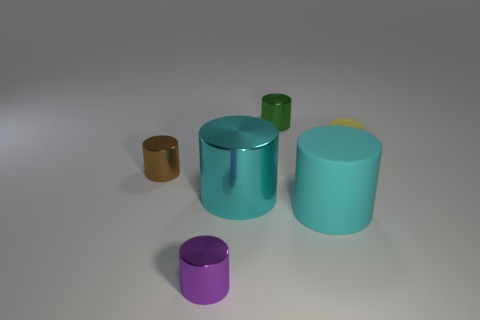Is there a rubber cylinder that has the same color as the big metallic cylinder?
Your response must be concise. Yes. Is the color of the rubber cylinder that is to the left of the yellow thing the same as the large metal cylinder?
Give a very brief answer. Yes. What is the material of the large cylinder that is the same color as the large metal thing?
Make the answer very short. Rubber. What is the material of the small object right of the cyan matte cylinder?
Your answer should be compact. Rubber. There is a cylinder that is in front of the big cyan rubber cylinder; does it have the same color as the tiny metallic thing that is behind the yellow matte cylinder?
Your answer should be compact. No. What number of things are large cyan metallic cylinders or tiny purple matte cylinders?
Keep it short and to the point. 1. What number of other things are there of the same shape as the large rubber object?
Provide a short and direct response. 5. Does the thing that is behind the yellow cylinder have the same material as the cyan thing on the right side of the green object?
Offer a terse response. No. There is a thing that is both behind the brown metallic thing and on the left side of the large matte cylinder; what shape is it?
Your answer should be very brief. Cylinder. The cylinder that is to the right of the tiny green shiny thing and behind the brown thing is made of what material?
Ensure brevity in your answer.  Rubber. 